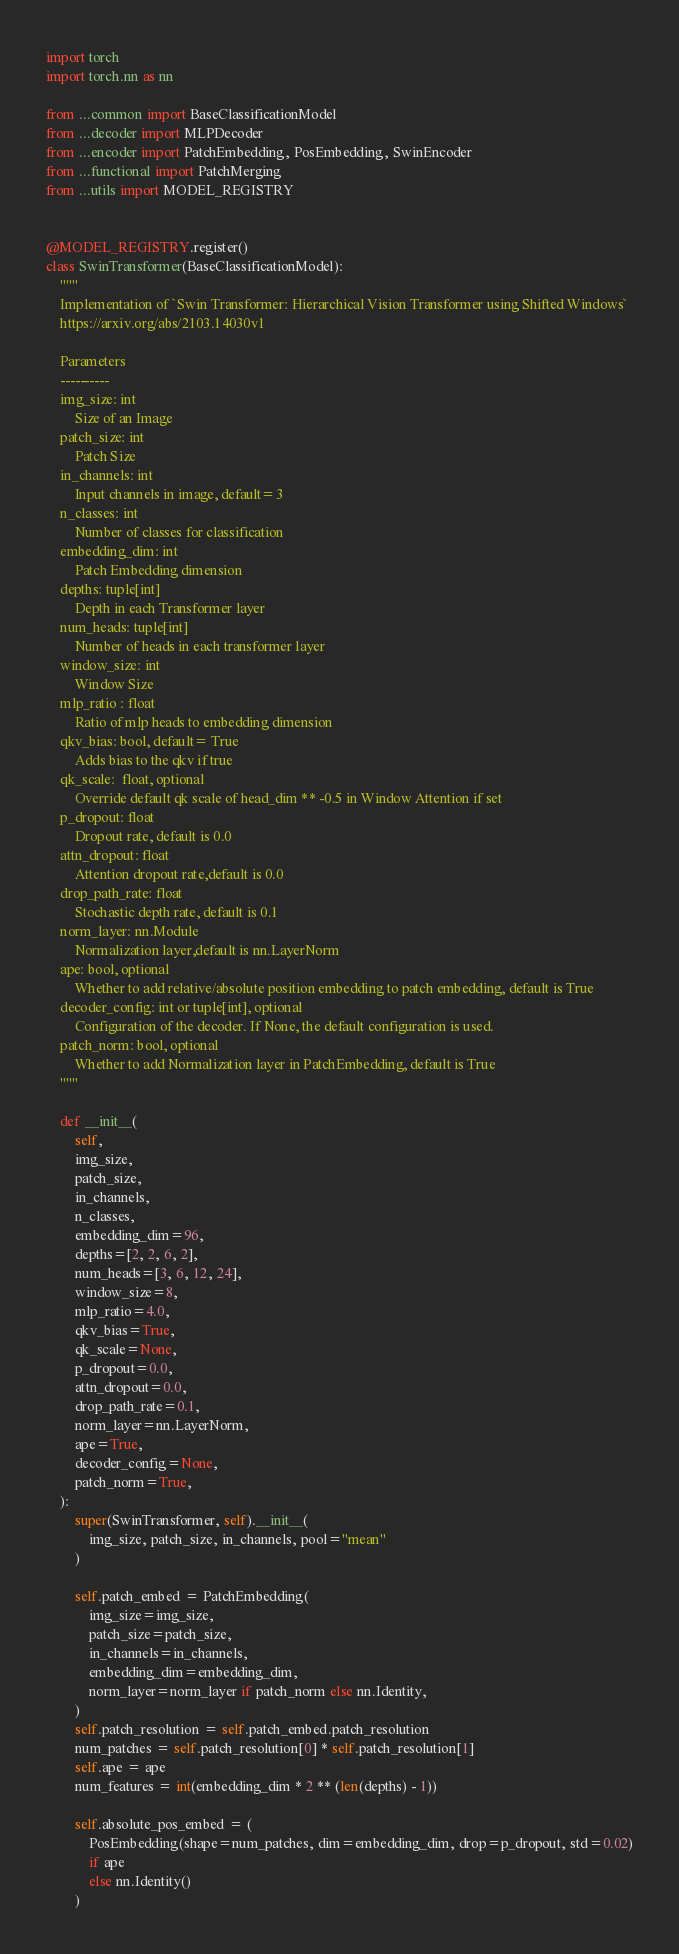<code> <loc_0><loc_0><loc_500><loc_500><_Python_>import torch
import torch.nn as nn

from ...common import BaseClassificationModel
from ...decoder import MLPDecoder
from ...encoder import PatchEmbedding, PosEmbedding, SwinEncoder
from ...functional import PatchMerging
from ...utils import MODEL_REGISTRY


@MODEL_REGISTRY.register()
class SwinTransformer(BaseClassificationModel):
    """
    Implementation of `Swin Transformer: Hierarchical Vision Transformer using Shifted Windows`
    https://arxiv.org/abs/2103.14030v1

    Parameters
    ----------
    img_size: int
        Size of an Image
    patch_size: int
        Patch Size
    in_channels: int
        Input channels in image, default=3
    n_classes: int
        Number of classes for classification
    embedding_dim: int
        Patch Embedding dimension
    depths: tuple[int]
        Depth in each Transformer layer
    num_heads: tuple[int]
        Number of heads in each transformer layer
    window_size: int
        Window Size
    mlp_ratio : float
        Ratio of mlp heads to embedding dimension
    qkv_bias: bool, default= True
        Adds bias to the qkv if true
    qk_scale:  float, optional
        Override default qk scale of head_dim ** -0.5 in Window Attention if set
    p_dropout: float
        Dropout rate, default is 0.0
    attn_dropout: float
        Attention dropout rate,default is 0.0
    drop_path_rate: float
        Stochastic depth rate, default is 0.1
    norm_layer: nn.Module
        Normalization layer,default is nn.LayerNorm
    ape: bool, optional
        Whether to add relative/absolute position embedding to patch embedding, default is True
    decoder_config: int or tuple[int], optional
        Configuration of the decoder. If None, the default configuration is used.
    patch_norm: bool, optional
        Whether to add Normalization layer in PatchEmbedding, default is True
    """

    def __init__(
        self,
        img_size,
        patch_size,
        in_channels,
        n_classes,
        embedding_dim=96,
        depths=[2, 2, 6, 2],
        num_heads=[3, 6, 12, 24],
        window_size=8,
        mlp_ratio=4.0,
        qkv_bias=True,
        qk_scale=None,
        p_dropout=0.0,
        attn_dropout=0.0,
        drop_path_rate=0.1,
        norm_layer=nn.LayerNorm,
        ape=True,
        decoder_config=None,
        patch_norm=True,
    ):
        super(SwinTransformer, self).__init__(
            img_size, patch_size, in_channels, pool="mean"
        )

        self.patch_embed = PatchEmbedding(
            img_size=img_size,
            patch_size=patch_size,
            in_channels=in_channels,
            embedding_dim=embedding_dim,
            norm_layer=norm_layer if patch_norm else nn.Identity,
        )
        self.patch_resolution = self.patch_embed.patch_resolution
        num_patches = self.patch_resolution[0] * self.patch_resolution[1]
        self.ape = ape
        num_features = int(embedding_dim * 2 ** (len(depths) - 1))

        self.absolute_pos_embed = (
            PosEmbedding(shape=num_patches, dim=embedding_dim, drop=p_dropout, std=0.02)
            if ape
            else nn.Identity()
        )</code> 